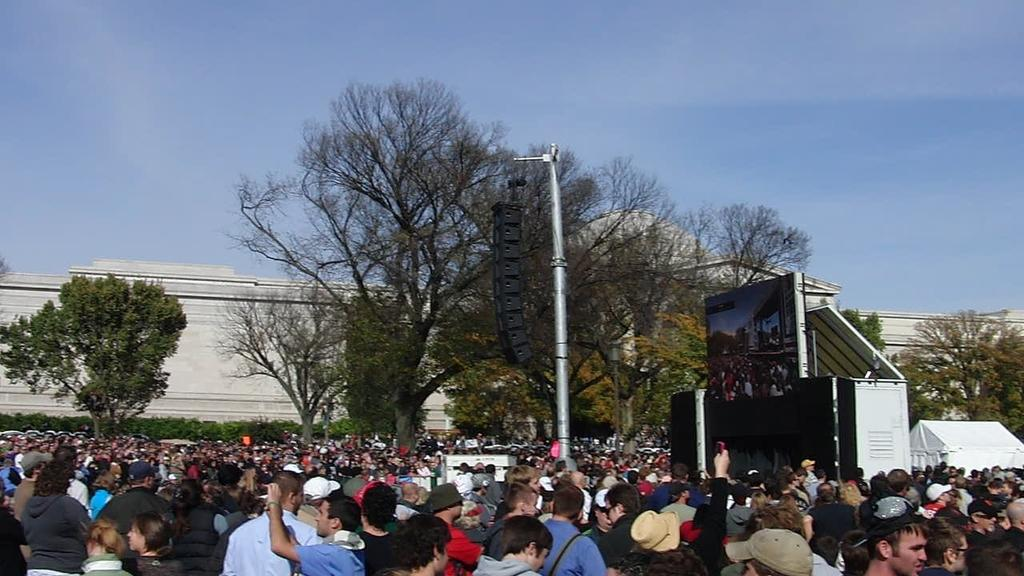What can be seen on the surface in the image? There are people on the surface in the image. What is present that might be used for displaying information or entertainment? There is a screen visible in the image. What might be used for amplifying sound in the image? There are speakers in the image. What type of natural vegetation is present in the image? There are trees in the image. What is visible in the sky in the image? Clouds are visible in the sky in the image. How many deer can be seen grazing in the image? There are no deer present in the image. What type of harmony is being played by the people in the image? There is no indication of music or harmony in the image; it only shows people, a screen, speakers, trees, and clouds. 